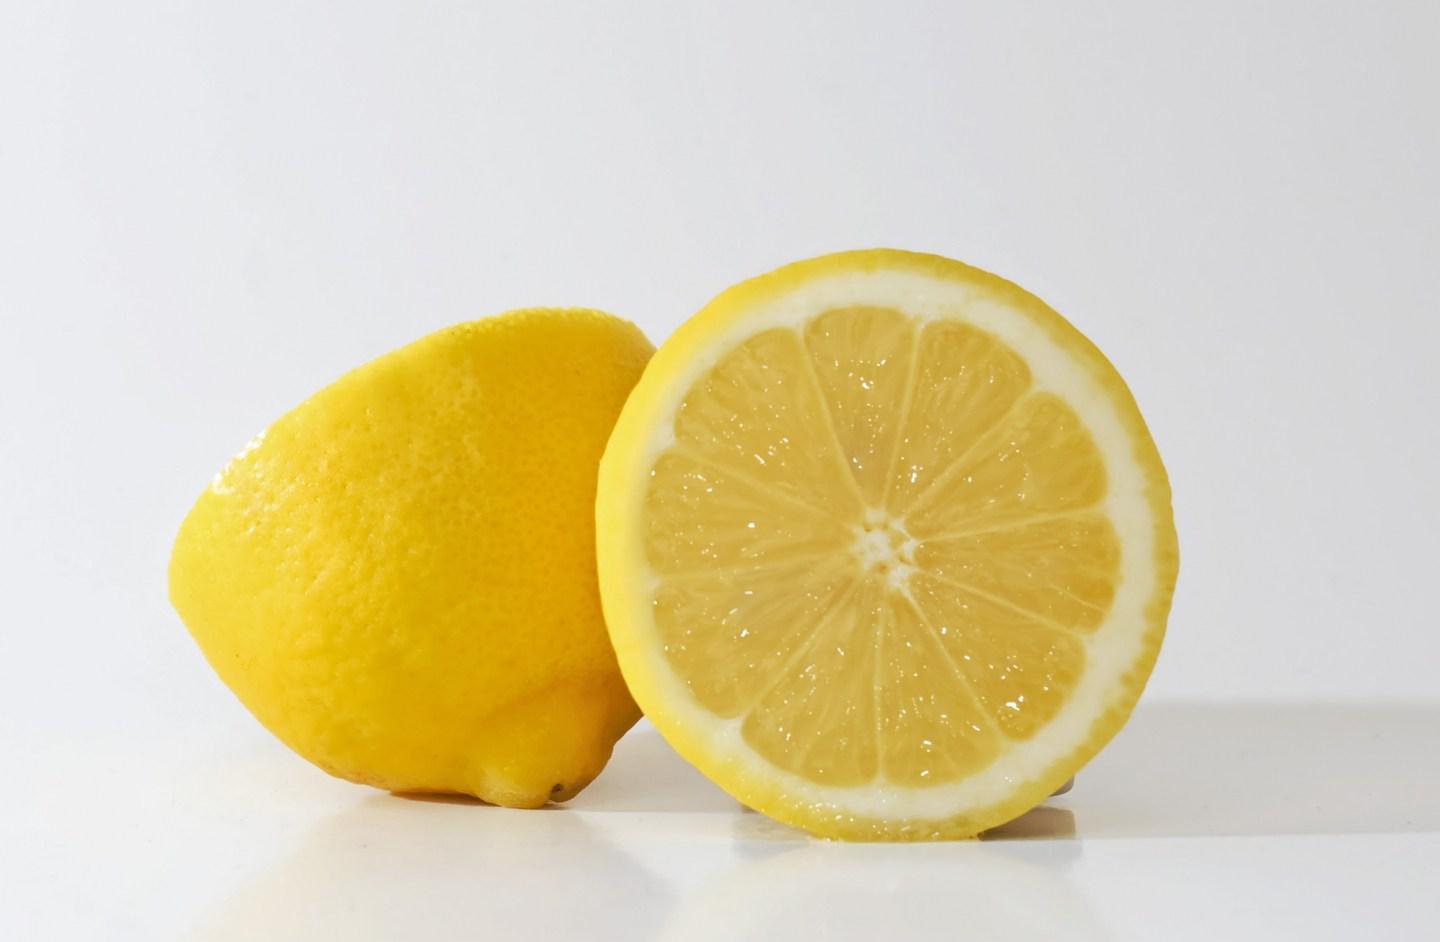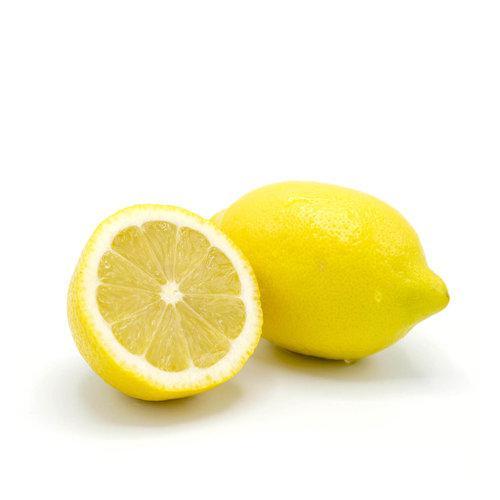The first image is the image on the left, the second image is the image on the right. For the images displayed, is the sentence "In at least one image there is at least one image with a full lemon and a lemon half cut horizontal." factually correct? Answer yes or no. Yes. The first image is the image on the left, the second image is the image on the right. Assess this claim about the two images: "Each image includes at least one whole lemon and one half lemon.". Correct or not? Answer yes or no. Yes. 